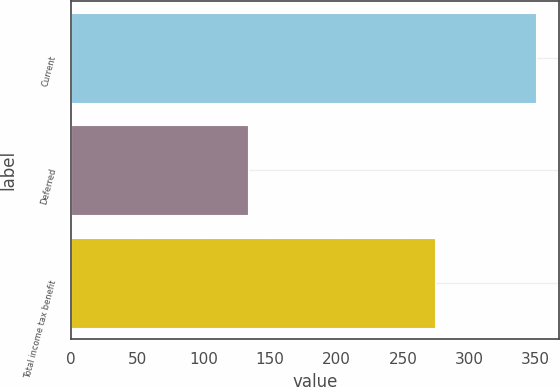<chart> <loc_0><loc_0><loc_500><loc_500><bar_chart><fcel>Current<fcel>Deferred<fcel>Total income tax benefit<nl><fcel>350<fcel>133<fcel>274<nl></chart> 